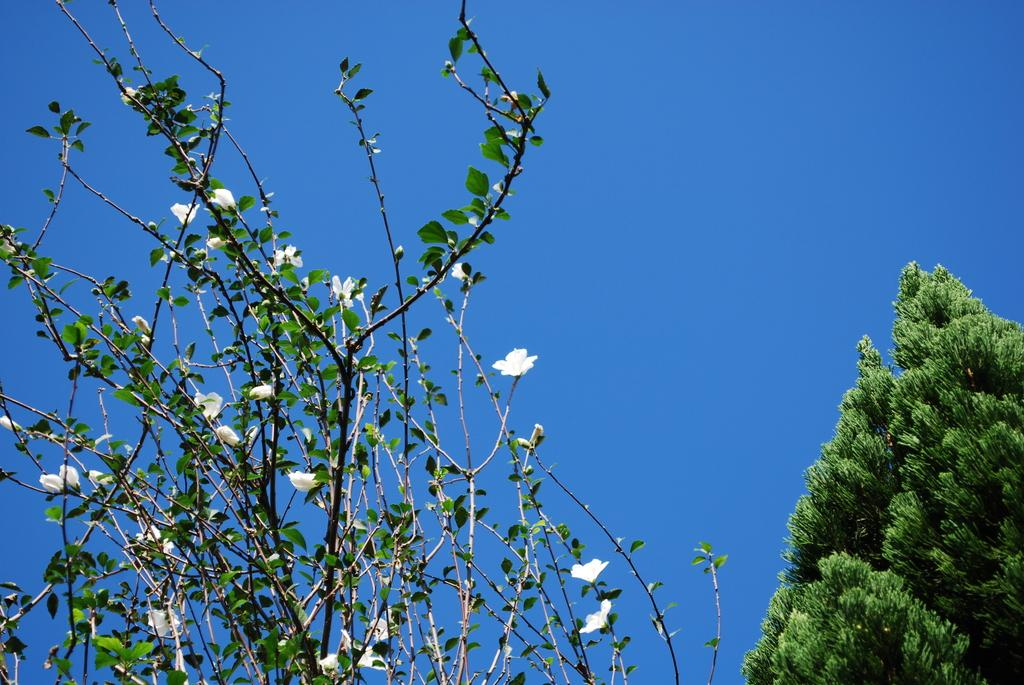What type of vegetation can be seen in the foreground of the image? There are flowers on a plant in the foreground of the image. What type of vegetation can be seen in the background of the image? There is a tree in the background of the image. What else is visible in the background of the image? The sky is visible in the background of the image. How many sisters are pushing the cart in the image? There is no cart or sisters present in the image. 